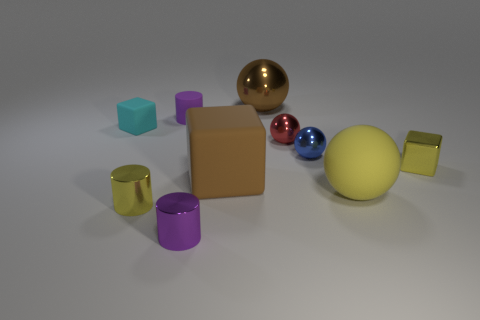There is a large brown object that is behind the tiny red ball; what material is it?
Your answer should be very brief. Metal. What is the size of the purple rubber cylinder?
Give a very brief answer. Small. What number of cyan things are either spheres or big matte balls?
Your response must be concise. 0. What is the size of the yellow object on the left side of the large rubber thing to the left of the red sphere?
Make the answer very short. Small. There is a small metallic block; is it the same color as the tiny cube that is on the left side of the small shiny block?
Give a very brief answer. No. How many other things are there of the same material as the small blue ball?
Ensure brevity in your answer.  5. There is a brown object that is made of the same material as the cyan object; what is its shape?
Provide a short and direct response. Cube. Is there anything else of the same color as the shiny cube?
Your answer should be very brief. Yes. The thing that is the same color as the big block is what size?
Your answer should be compact. Large. Is the number of small shiny objects that are behind the small matte cylinder greater than the number of tiny cubes?
Give a very brief answer. No. 